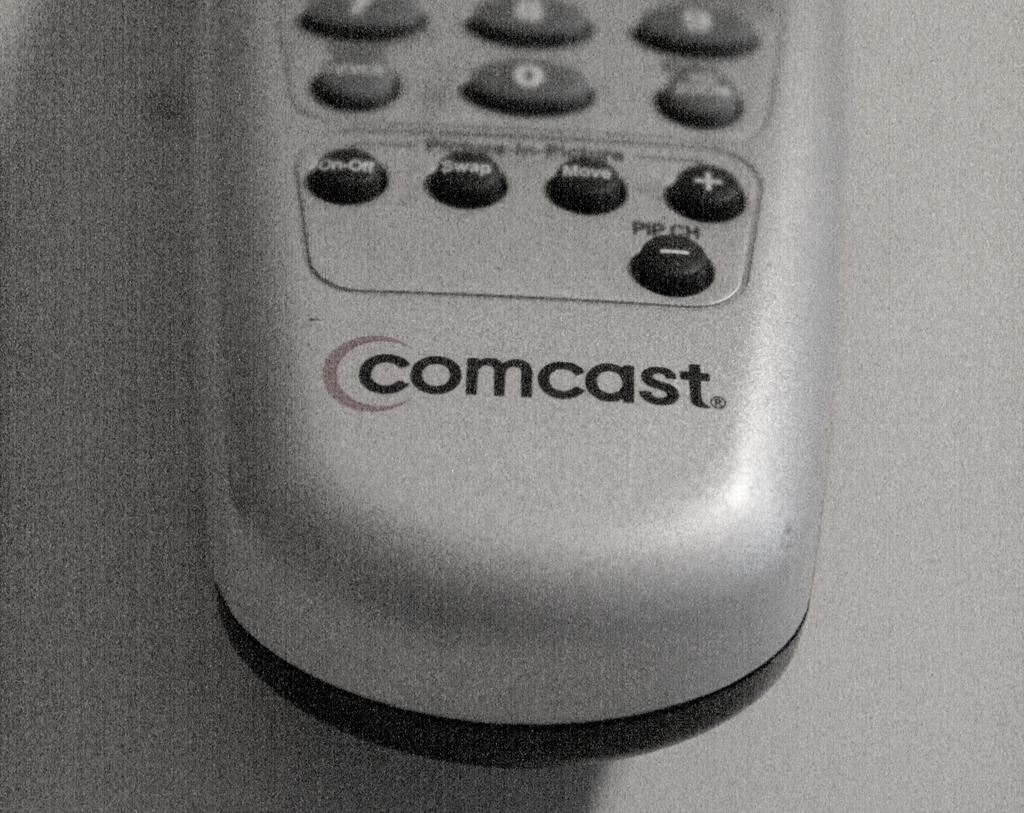Provide a one-sentence caption for the provided image. A silver comcast remote is set on a table. 